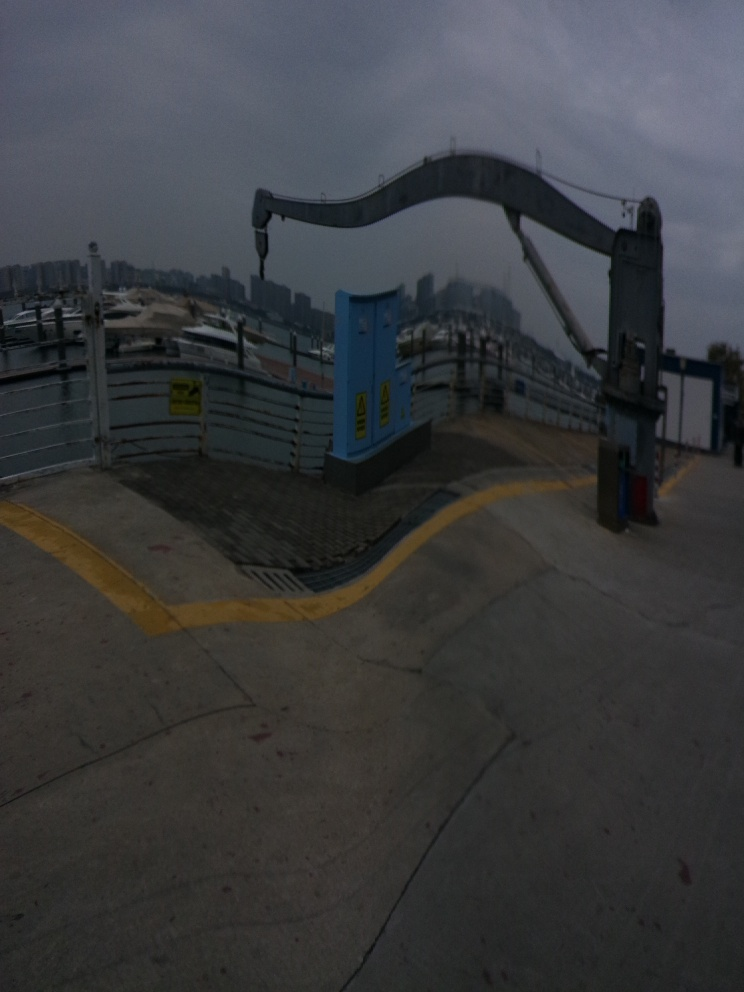What can we infer about the time of day and weather conditions in this image? The overcast sky and diffused lighting indicate a cloudy day, with no strong shadows present. This type of lighting is often associated with early morning or late afternoon. Additionally, the absence of active workers or bright sunlight suggests it's not midday when such an industrial area would typically be bustling. Overall, the weather conditions seem somber, possibly indicating an approaching storm or just a typical cloudy day in a coastal or riverine city. 